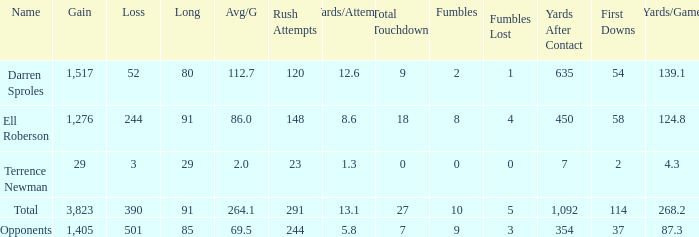When the Gain is 29, and the average per game is 2, and the player lost less than 390 yards, what's the sum of the Long yards? None. Parse the table in full. {'header': ['Name', 'Gain', 'Loss', 'Long', 'Avg/G', 'Rush Attempts', 'Yards/Attempt', 'Total Touchdowns', 'Fumbles', 'Fumbles Lost', 'Yards After Contact', 'First Downs', 'Yards/Game'], 'rows': [['Darren Sproles', '1,517', '52', '80', '112.7', '120', '12.6', '9', '2', '1', '635', '54', '139.1'], ['Ell Roberson', '1,276', '244', '91', '86.0', '148', '8.6', '18', '8', '4', '450', '58', '124.8'], ['Terrence Newman', '29', '3', '29', '2.0', '23', '1.3', '0', '0', '0', '7', '2', '4.3'], ['Total', '3,823', '390', '91', '264.1', '291', '13.1', '27', '10', '5', '1,092', '114', '268.2'], ['Opponents', '1,405', '501', '85', '69.5', '244', '5.8', '7', '9', '3', '354', '37', '87.3']]} 